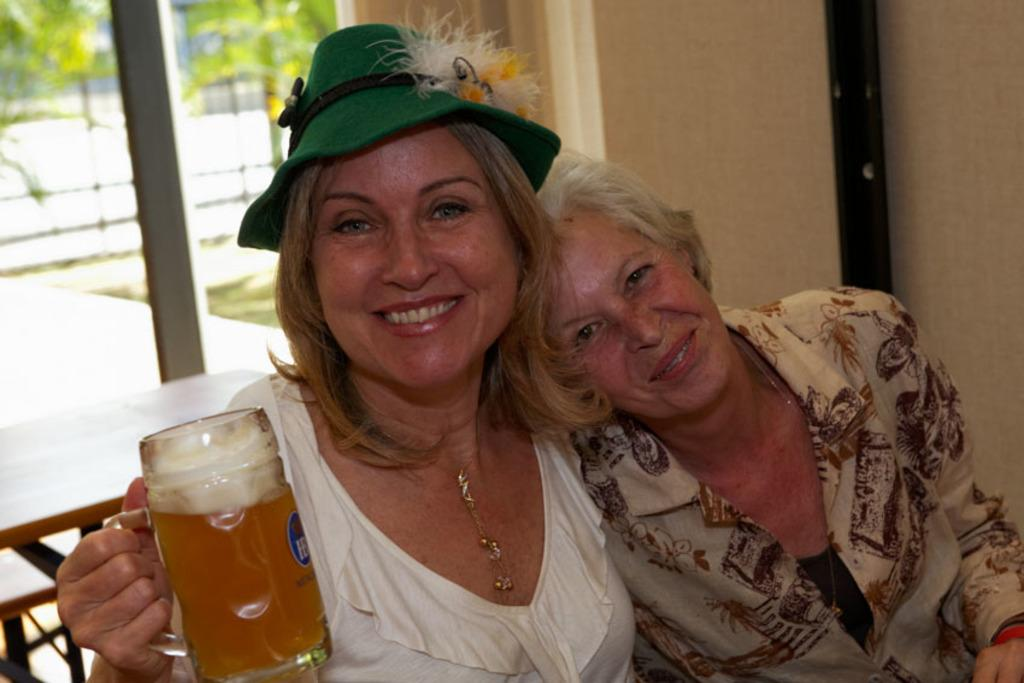How many women are in the image? There are two women in the image. What expressions do the women have? Both women are smiling. What is the woman on the left side holding? The woman on the left side is holding a cup. What can be seen on the head of the woman on the left side? The woman on the left side is wearing a green hat. What type of sugar is being used by the secretary in the image? There is no secretary or sugar present in the image. Is there a sock visible on the foot of either woman in the image? There is no sock visible on the feet of either woman in the image. 